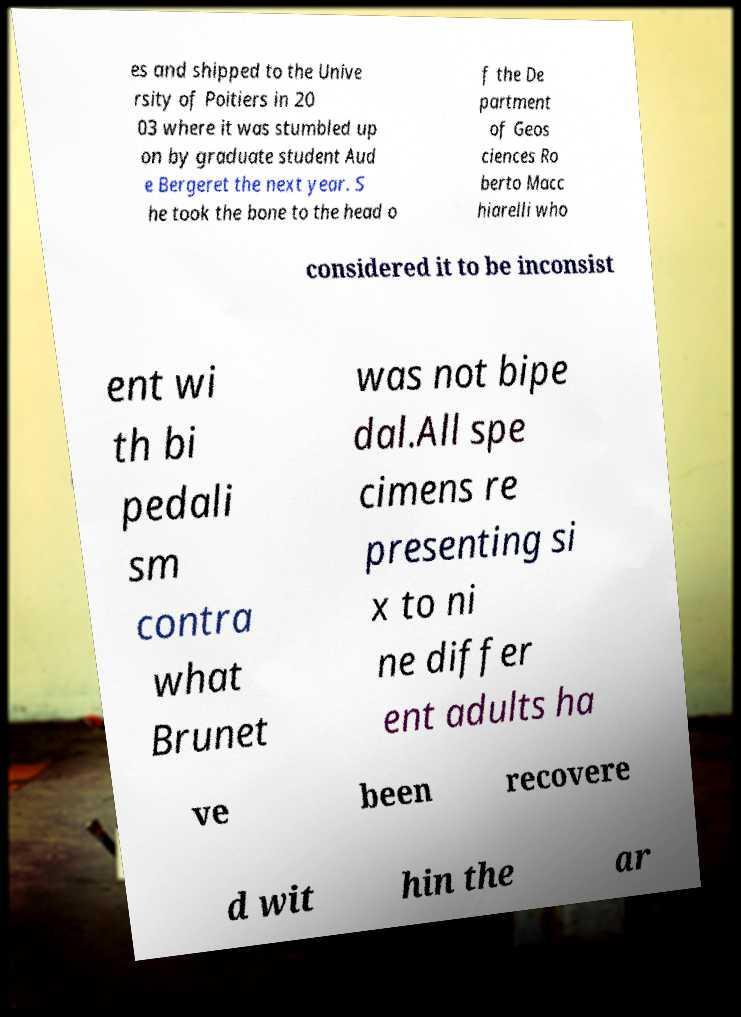Can you accurately transcribe the text from the provided image for me? es and shipped to the Unive rsity of Poitiers in 20 03 where it was stumbled up on by graduate student Aud e Bergeret the next year. S he took the bone to the head o f the De partment of Geos ciences Ro berto Macc hiarelli who considered it to be inconsist ent wi th bi pedali sm contra what Brunet was not bipe dal.All spe cimens re presenting si x to ni ne differ ent adults ha ve been recovere d wit hin the ar 